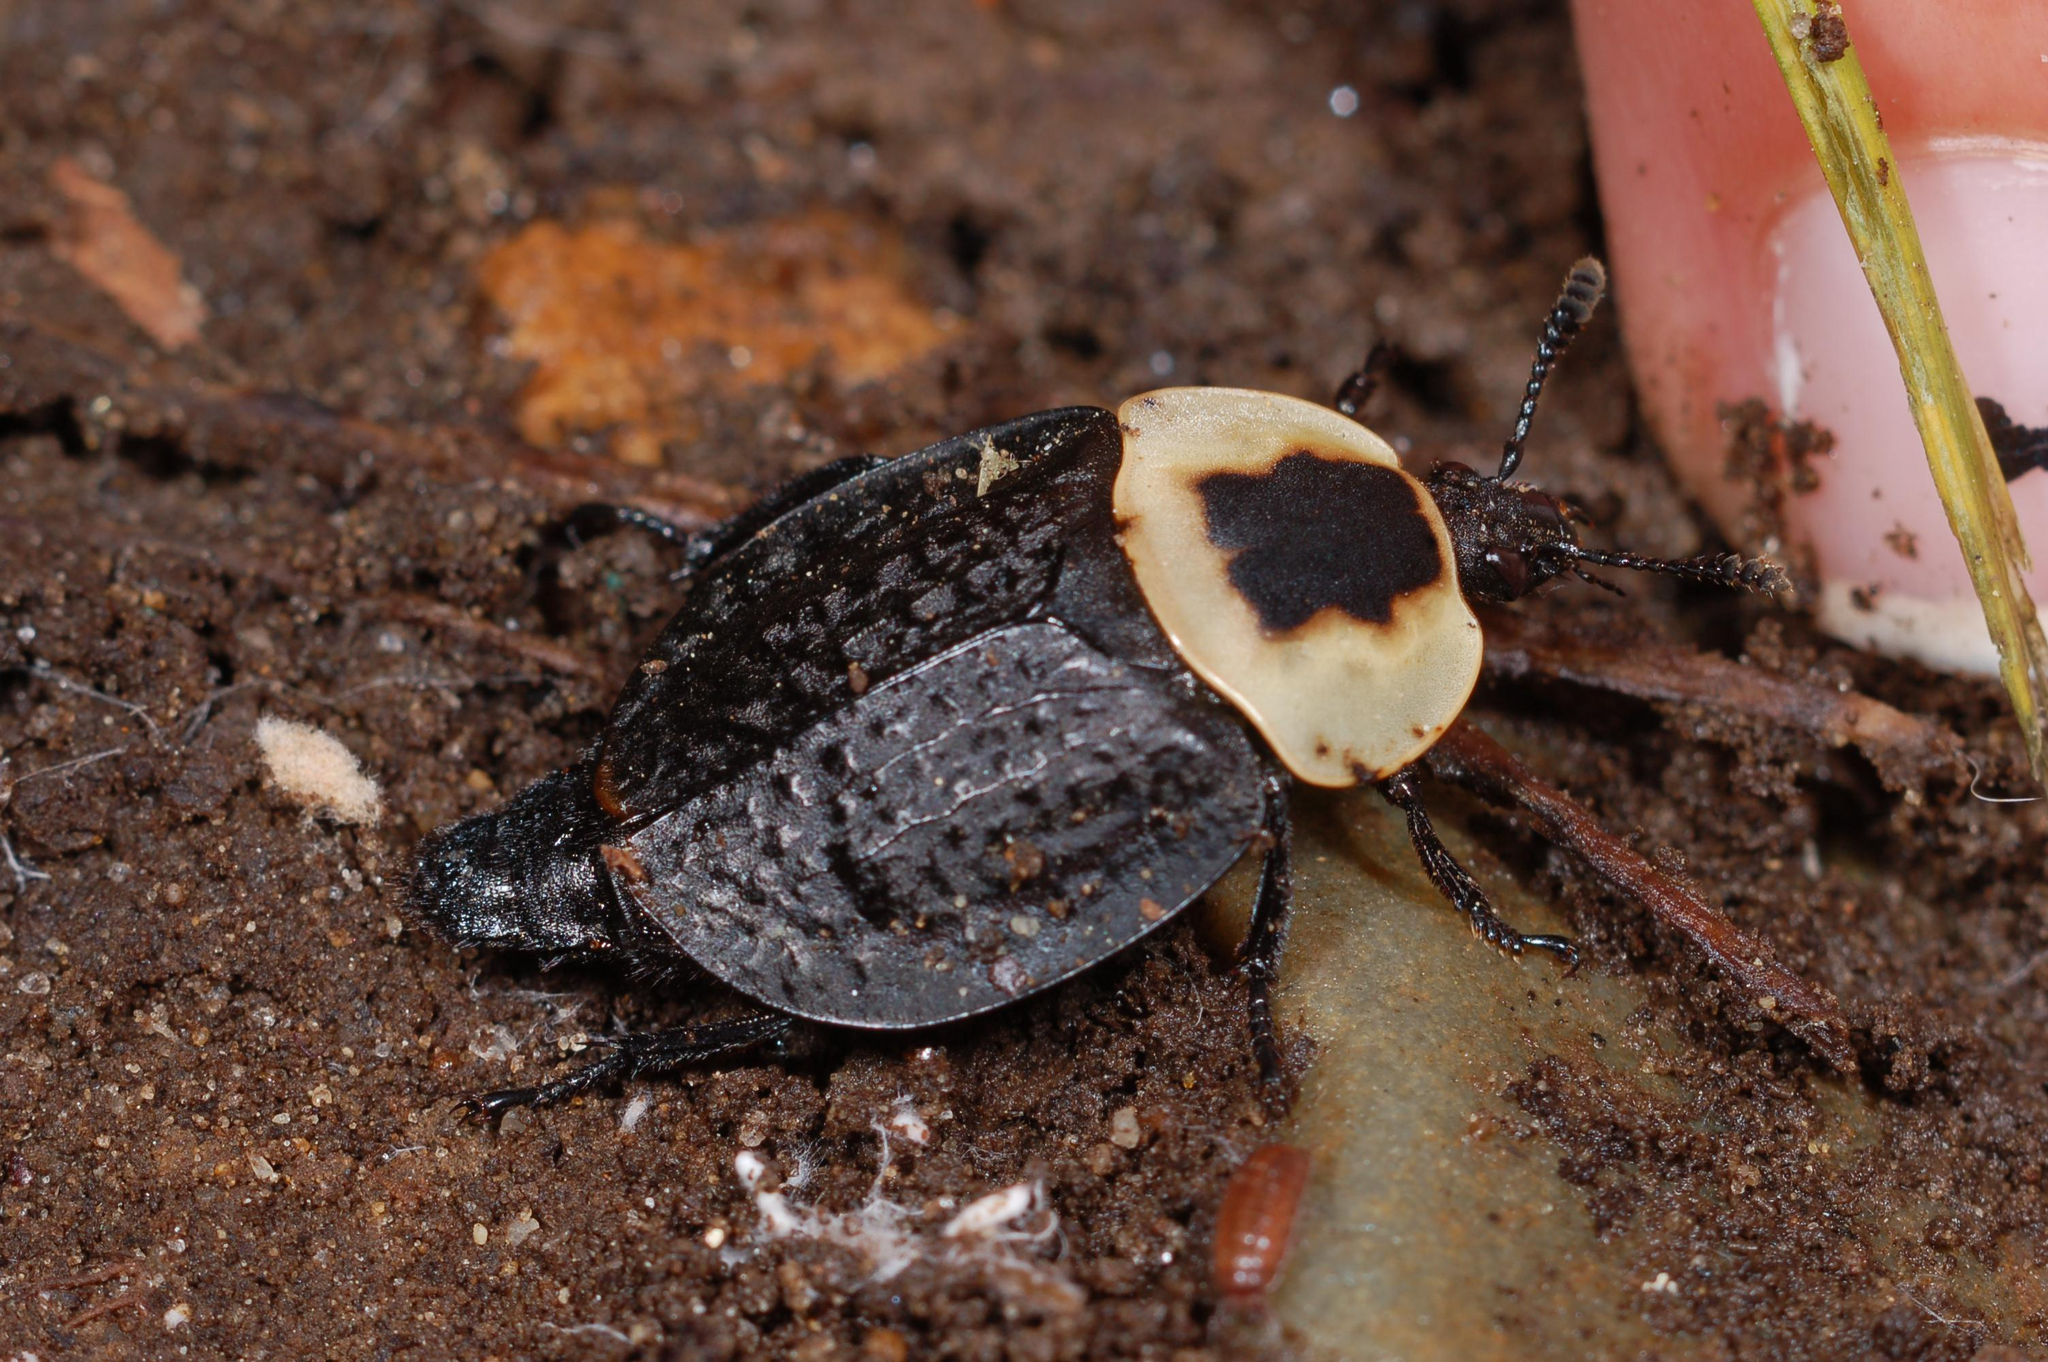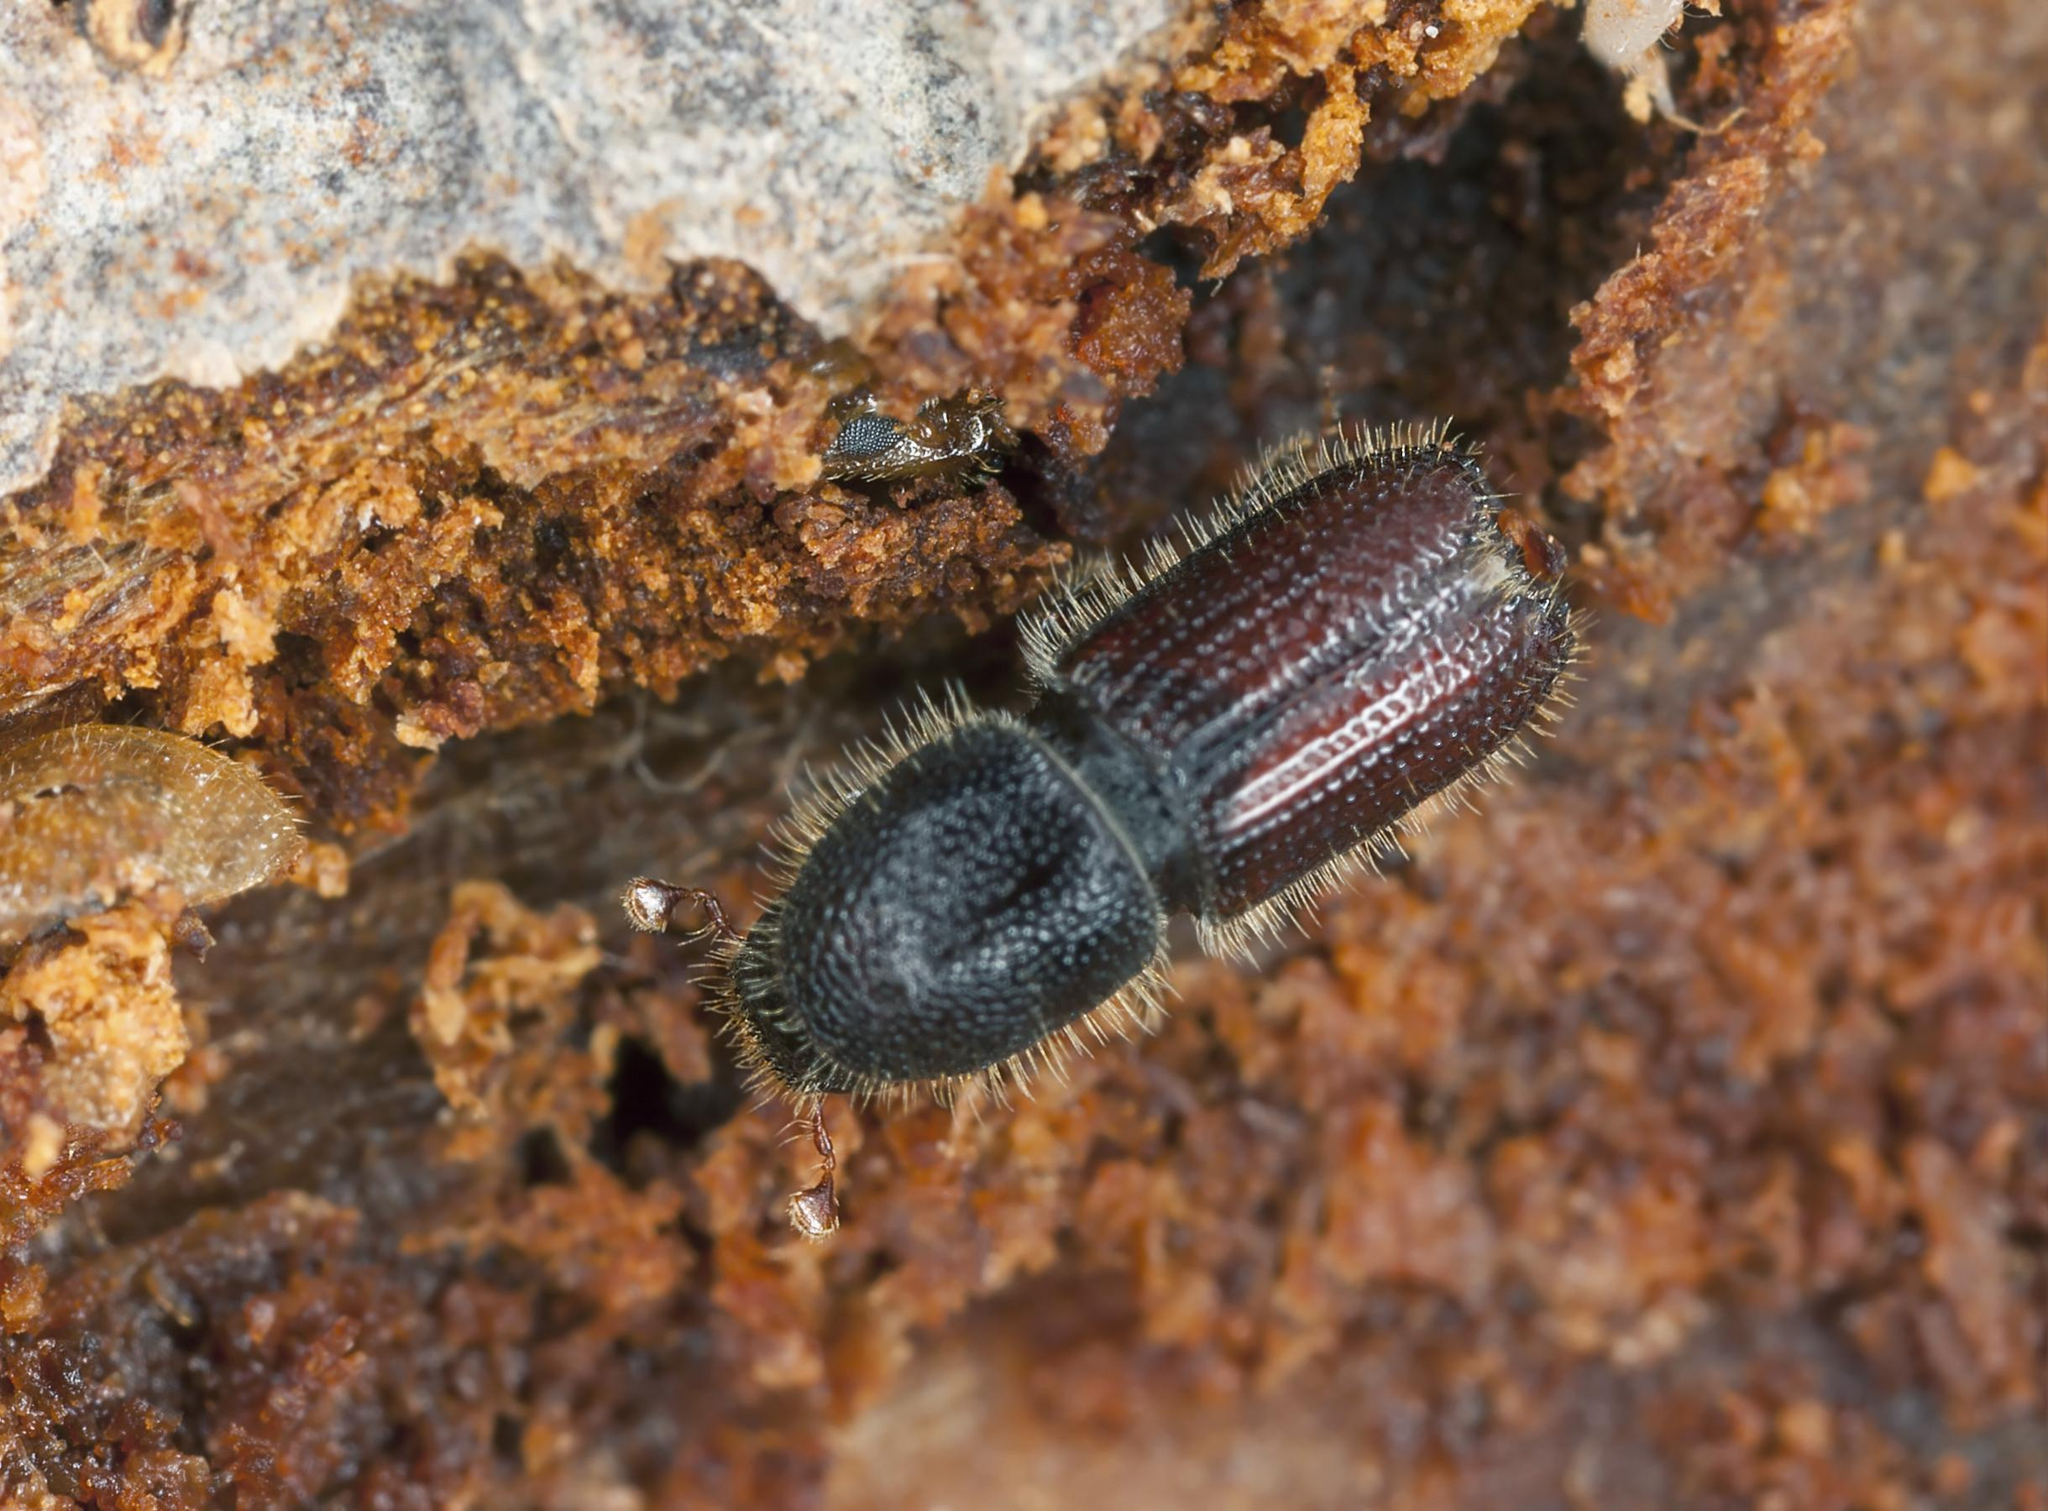The first image is the image on the left, the second image is the image on the right. For the images shown, is this caption "Each image includes a beetle in contact with a round dung ball." true? Answer yes or no. No. The first image is the image on the left, the second image is the image on the right. Examine the images to the left and right. Is the description "A beetle is on a dung ball." accurate? Answer yes or no. No. 